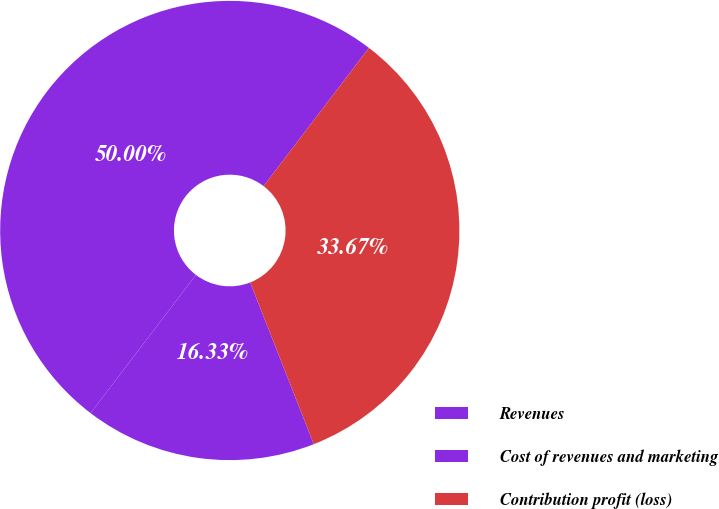Convert chart. <chart><loc_0><loc_0><loc_500><loc_500><pie_chart><fcel>Revenues<fcel>Cost of revenues and marketing<fcel>Contribution profit (loss)<nl><fcel>16.33%<fcel>50.0%<fcel>33.67%<nl></chart> 